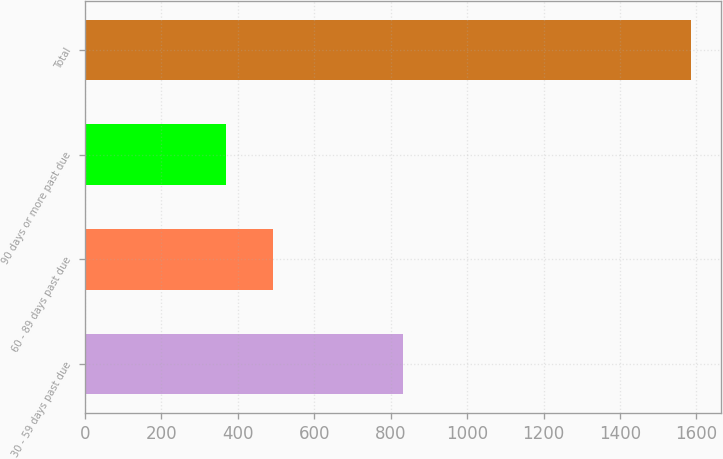Convert chart. <chart><loc_0><loc_0><loc_500><loc_500><bar_chart><fcel>30 - 59 days past due<fcel>60 - 89 days past due<fcel>90 days or more past due<fcel>Total<nl><fcel>833<fcel>491.5<fcel>370<fcel>1585<nl></chart> 